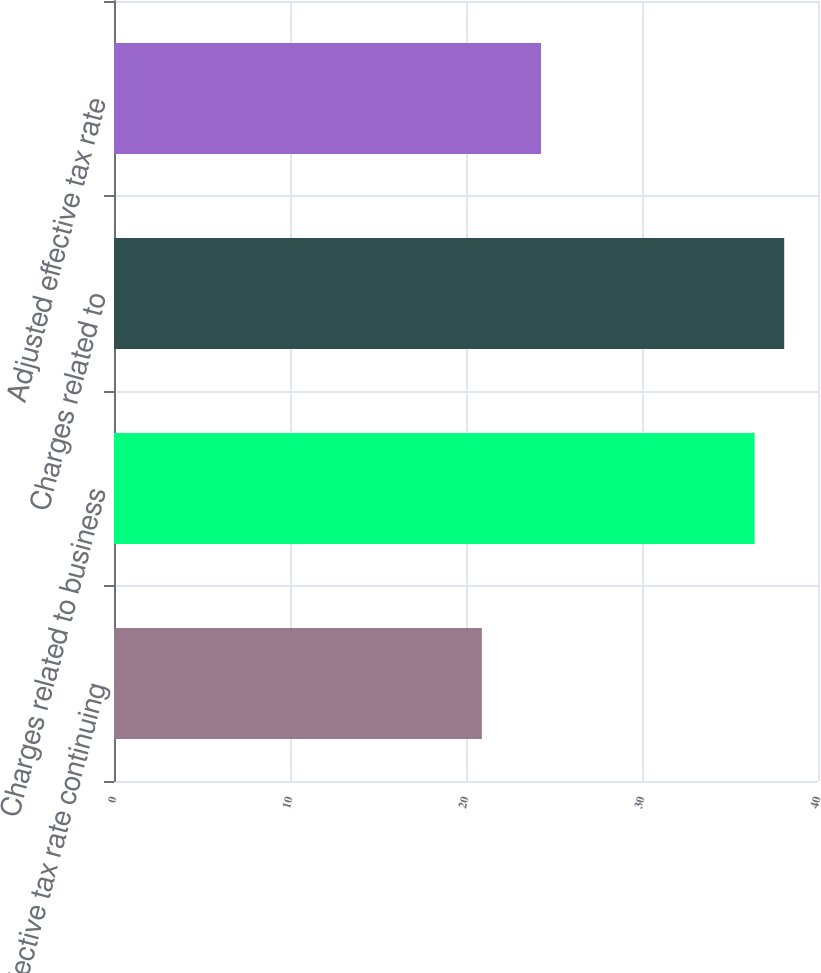Convert chart. <chart><loc_0><loc_0><loc_500><loc_500><bar_chart><fcel>Effective tax rate continuing<fcel>Charges related to business<fcel>Charges related to<fcel>Adjusted effective tax rate<nl><fcel>20.9<fcel>36.4<fcel>38.08<fcel>24.26<nl></chart> 